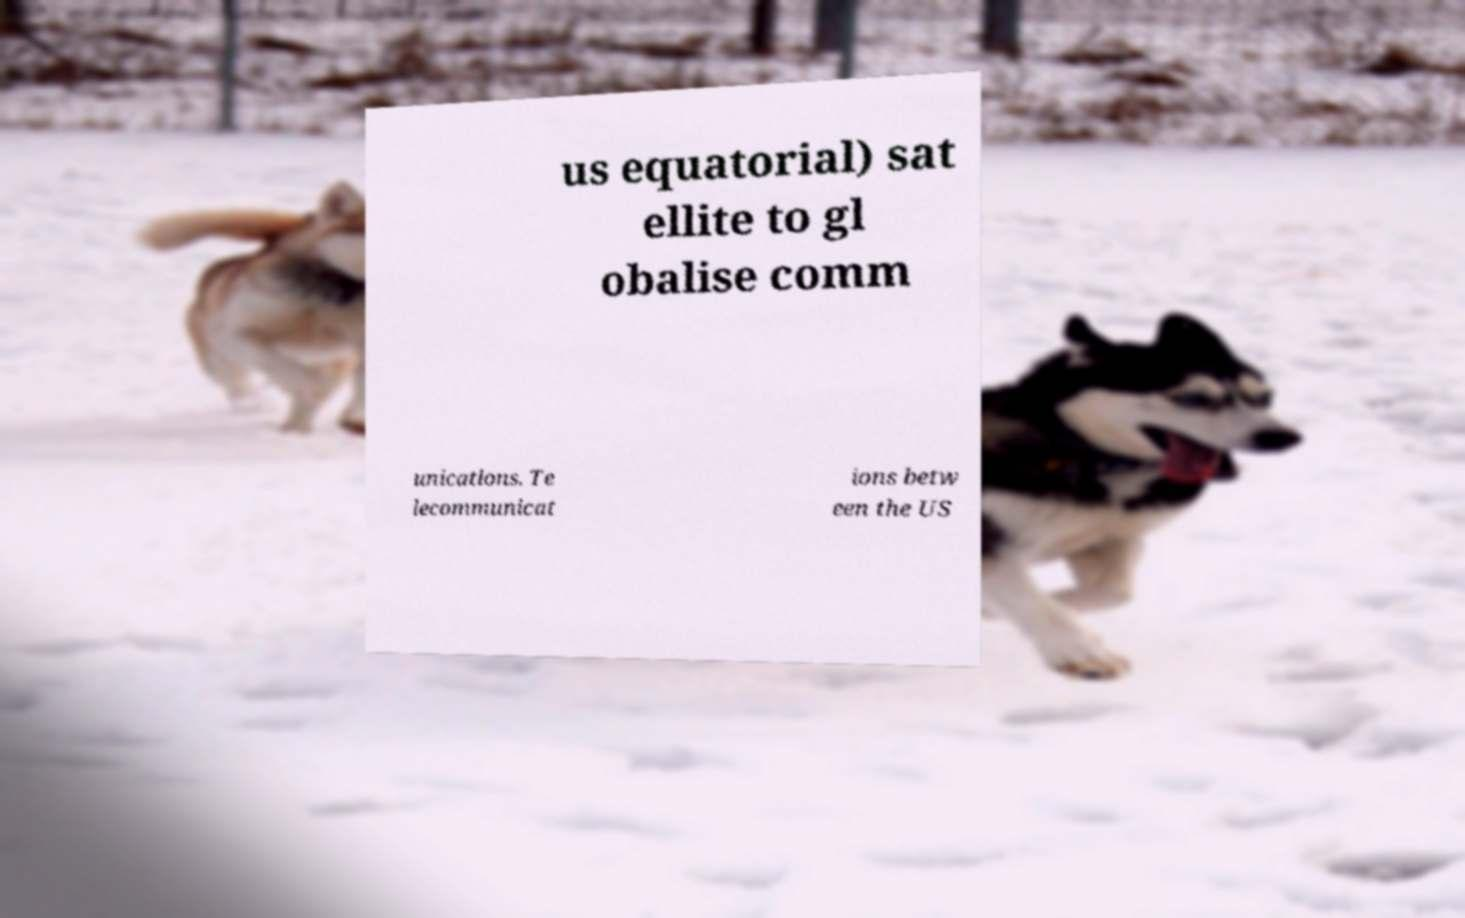There's text embedded in this image that I need extracted. Can you transcribe it verbatim? us equatorial) sat ellite to gl obalise comm unications. Te lecommunicat ions betw een the US 